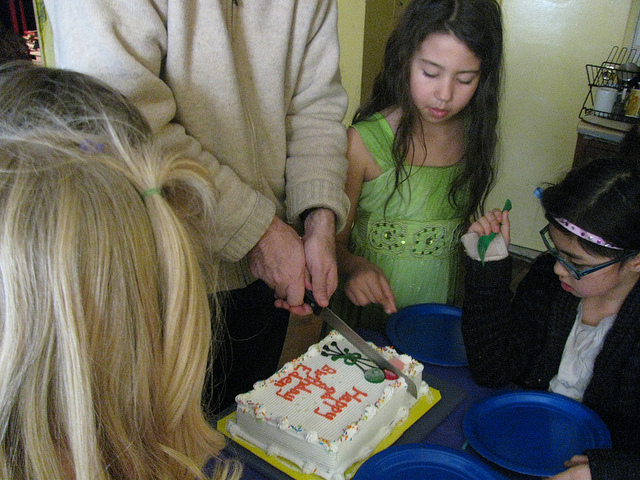Identify and read out the text in this image. Happy Birthday Eden 